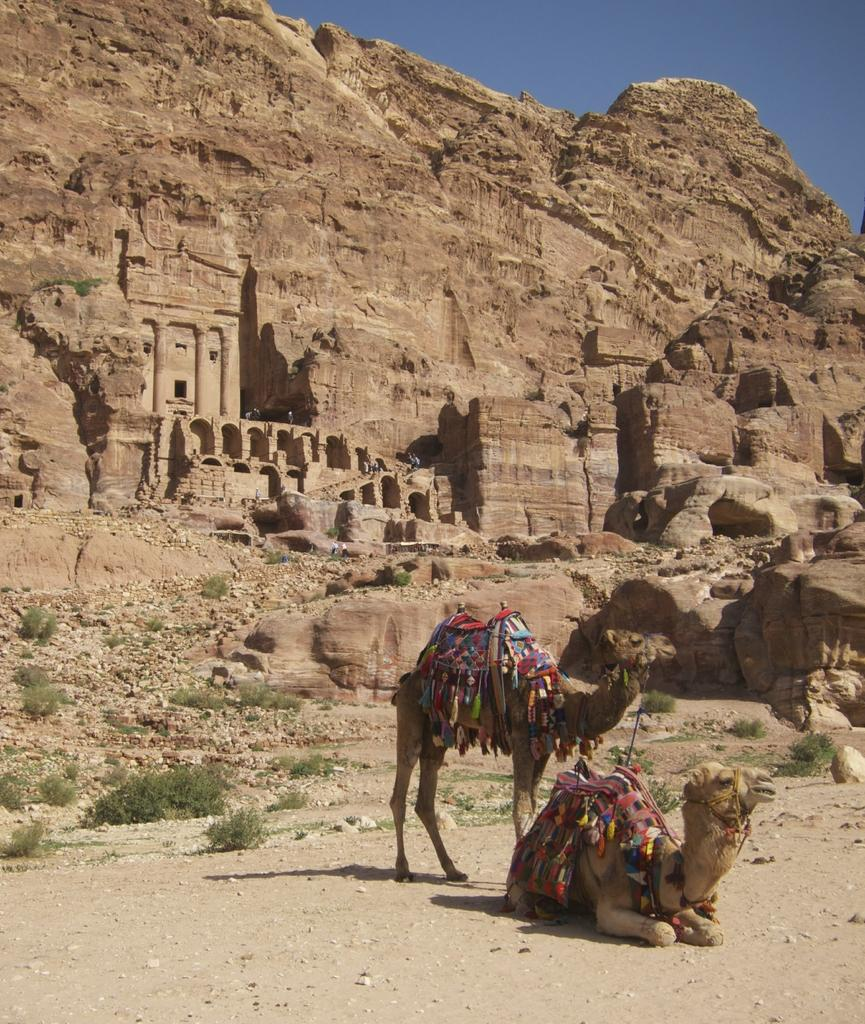What animals are present in the image? There are camels in the image. What else can be seen near the camels? There are plants beside the camels. What can be seen in the distance in the image? There is a fort visible in the background of the image, and there is also a hill in the background. What type of root vegetable is being harvested with a spade in the image? There is no root vegetable or spade present in the image. Can you see a swing in the image? No, there is no swing present in the image. 